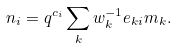Convert formula to latex. <formula><loc_0><loc_0><loc_500><loc_500>n _ { i } = q ^ { c _ { i } } \sum _ { k } w _ { k } ^ { - 1 } e _ { k i } m _ { k } .</formula> 